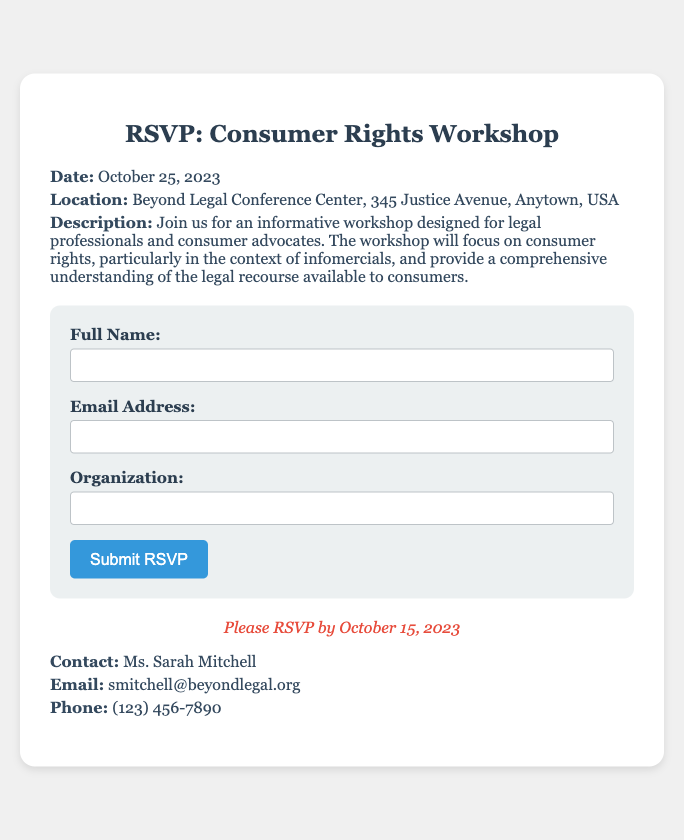What is the date of the workshop? The date of the workshop is explicitly mentioned in the document as October 25, 2023.
Answer: October 25, 2023 Where is the workshop located? The location of the workshop is stated in the document, specifically at Beyond Legal Conference Center, 345 Justice Avenue, Anytown, USA.
Answer: Beyond Legal Conference Center, 345 Justice Avenue, Anytown, USA What is the RSVP deadline? The RSVP deadline is provided in the document as October 15, 2023, which is important for potential attendees.
Answer: October 15, 2023 Who is the contact person for the workshop? The document specifies Ms. Sarah Mitchell as the contact person for any inquiries regarding the workshop.
Answer: Ms. Sarah Mitchell What is the main focus of the workshop? The main focus of the workshop is outlined in the document, centering on consumer rights and issues related to infomercials.
Answer: Consumer rights and infomercials What type of audience is the workshop intended for? The document describes the target audience for the workshop as legal professionals and consumer advocates, indicating a professional focus.
Answer: Legal professionals and consumer advocates What should potential attendees submit? According to the document, potential attendees need to submit their RSVP to participate in the workshop.
Answer: RSVP What is included in the RSVP form? The document lists several fields in the RSVP form, including Full Name, Email Address, and Organization, which attendees need to complete.
Answer: Full Name, Email Address, Organization 